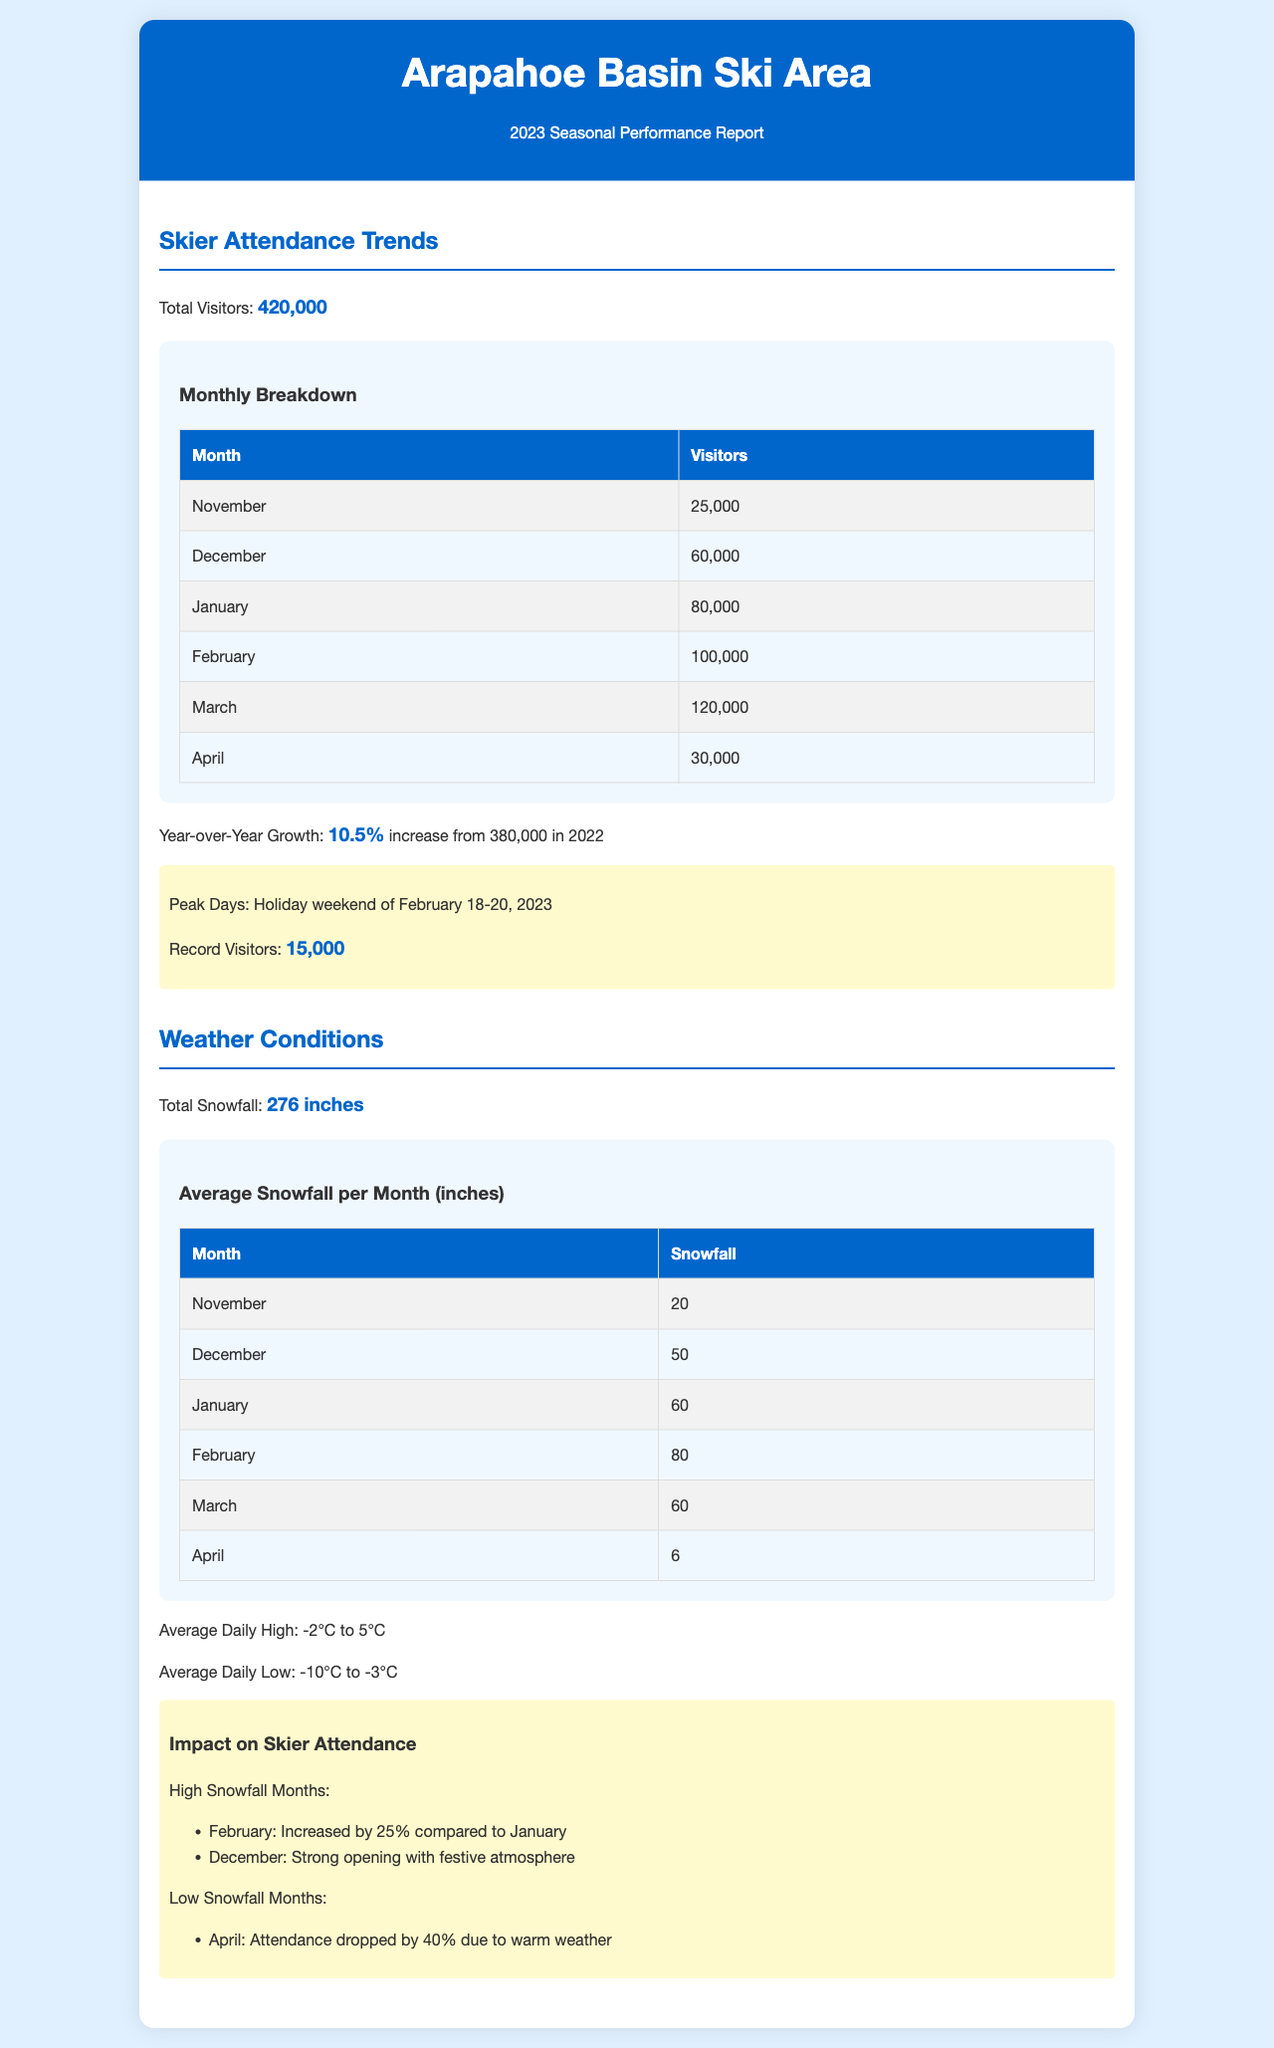What was the total skier attendance for the season? The total skier attendance is explicitly stated as 420,000 visitors.
Answer: 420,000 What was the total snowfall recorded at Arapahoe Basin? The total snowfall is summarized in the document as 276 inches.
Answer: 276 inches Which month had the highest number of visitors? The table shows that March had the highest attendance with 120,000 visitors.
Answer: March What was the percentage increase in year-over-year growth? The report states that year-over-year growth was a 10.5% increase from 380,000 in 2022.
Answer: 10.5% What were the peak days for skier attendance? The peak days are noted as February 18-20, 2023, during the holiday weekend.
Answer: February 18-20, 2023 How much did attendance change in February compared to January? The document mentions a 25% increase in skier attendance in February compared to January.
Answer: 25% What was the average daily high temperature during the season? The average daily high temperature is presented as ranging from -2°C to 5°C.
Answer: -2°C to 5°C Which month experienced a drop in attendance due to warm weather? The report indicates that attendance dropped in April due to warm weather.
Answer: April What was the snowfall amount for the month of January? The snowfall for January is listed as 60 inches.
Answer: 60 inches 